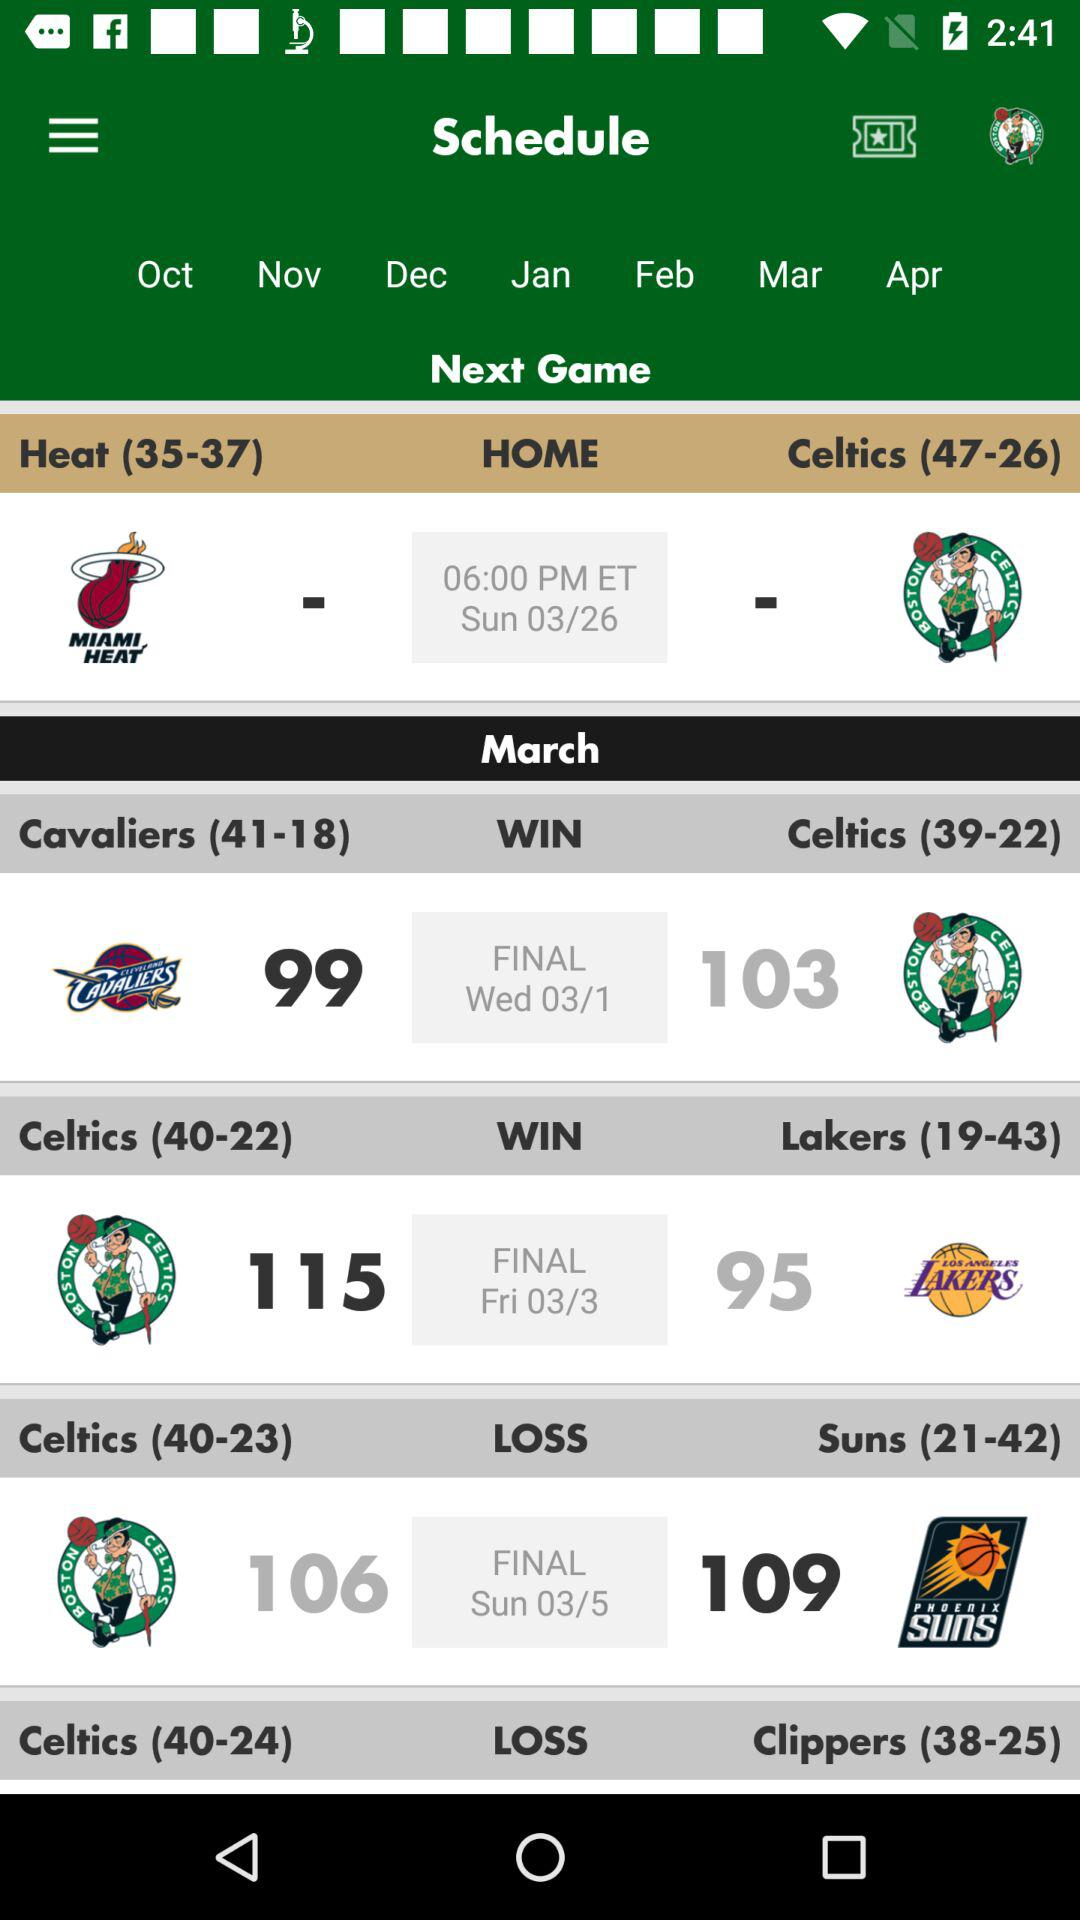Which is the next match? The next match is between the Heat and the Celtics. 